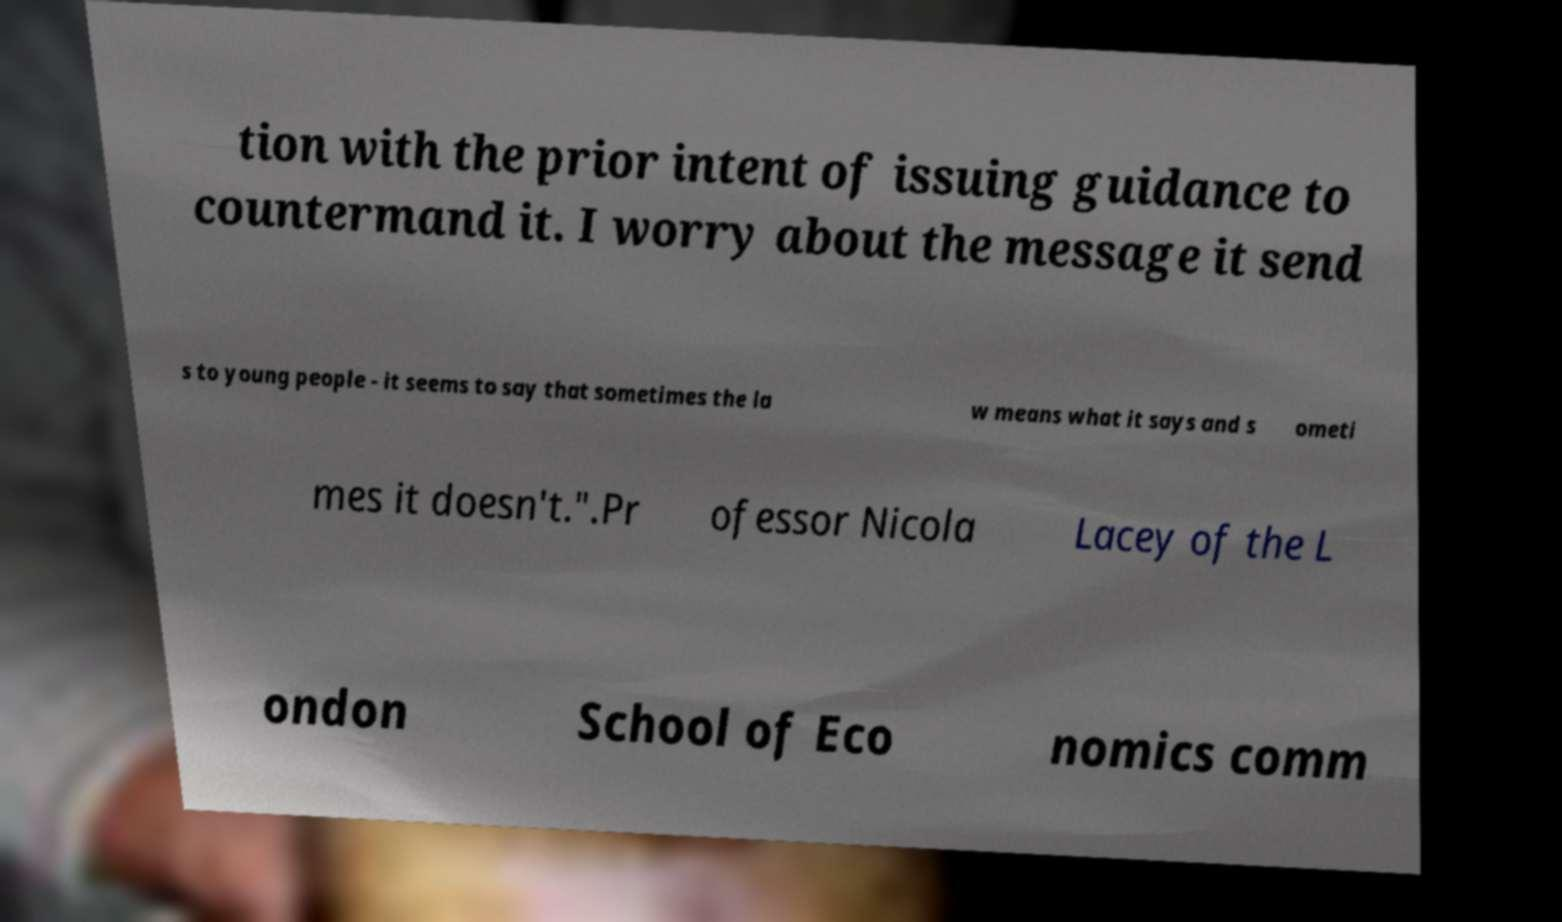Could you extract and type out the text from this image? tion with the prior intent of issuing guidance to countermand it. I worry about the message it send s to young people - it seems to say that sometimes the la w means what it says and s ometi mes it doesn't.".Pr ofessor Nicola Lacey of the L ondon School of Eco nomics comm 